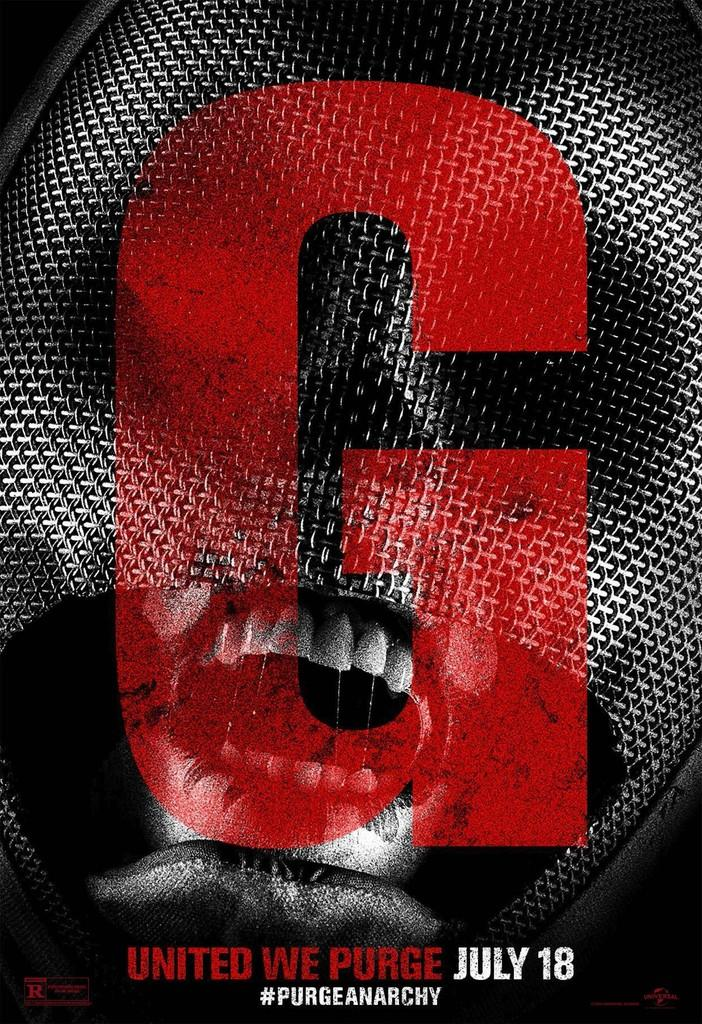<image>
Give a short and clear explanation of the subsequent image. An ad for a movie has a large G on the front and a date of July 18. 